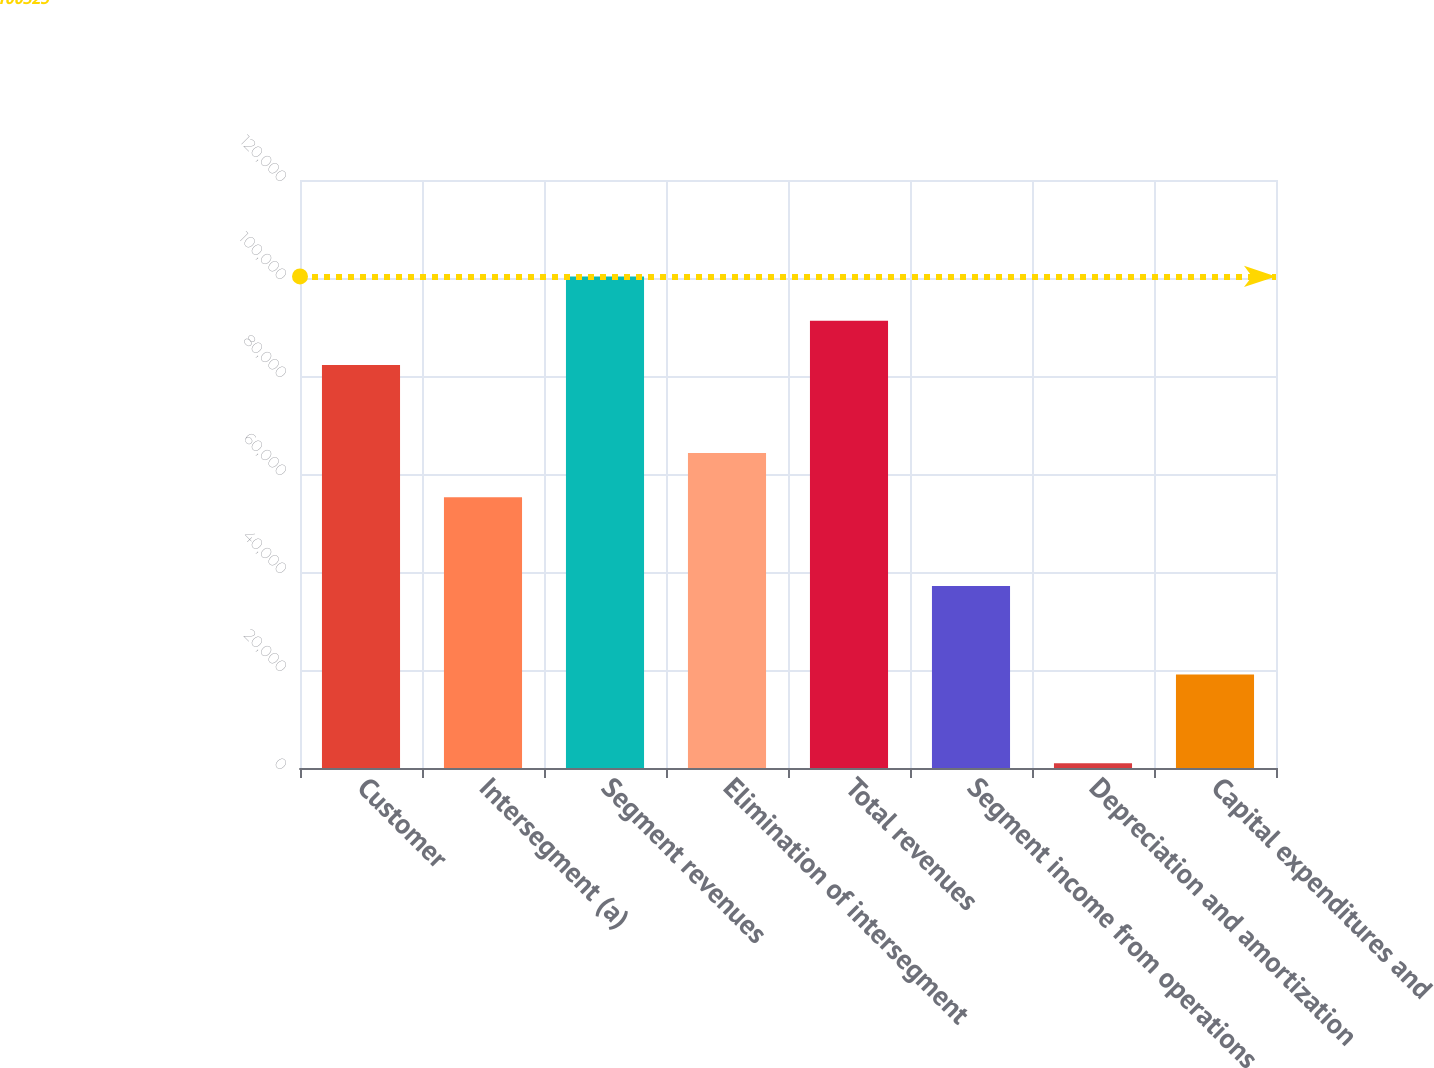<chart> <loc_0><loc_0><loc_500><loc_500><bar_chart><fcel>Customer<fcel>Intersegment (a)<fcel>Segment revenues<fcel>Elimination of intersegment<fcel>Total revenues<fcel>Segment income from operations<fcel>Depreciation and amortization<fcel>Capital expenditures and<nl><fcel>82237<fcel>55236<fcel>100325<fcel>64280<fcel>91281<fcel>37148<fcel>972<fcel>19060<nl></chart> 